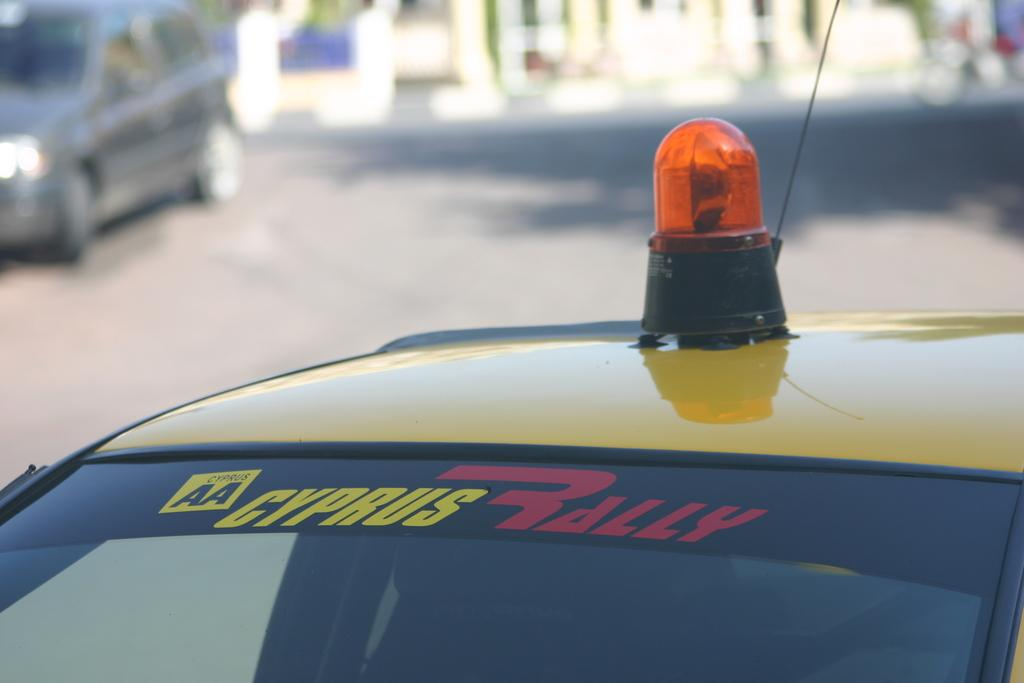<image>
Offer a succinct explanation of the picture presented. A yellow car with an orange light on top says Cypress Rally on the windshield. 